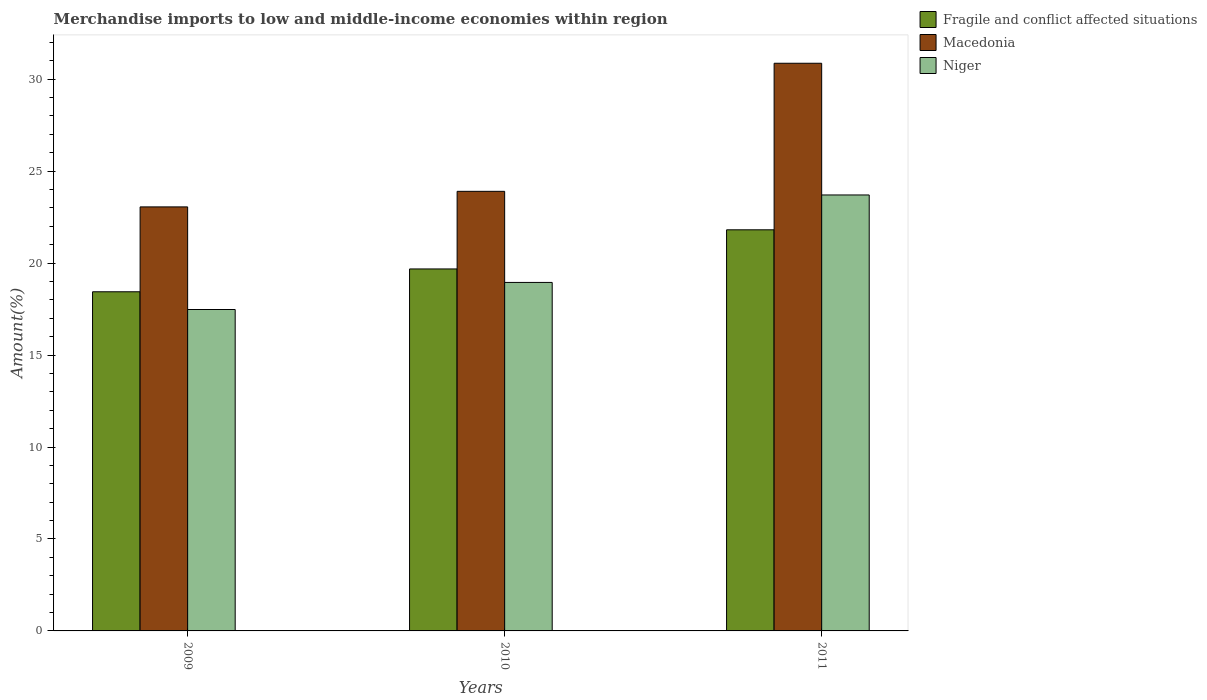How many different coloured bars are there?
Your response must be concise. 3. How many groups of bars are there?
Your answer should be compact. 3. Are the number of bars per tick equal to the number of legend labels?
Give a very brief answer. Yes. How many bars are there on the 1st tick from the left?
Your response must be concise. 3. What is the label of the 3rd group of bars from the left?
Your response must be concise. 2011. In how many cases, is the number of bars for a given year not equal to the number of legend labels?
Offer a terse response. 0. What is the percentage of amount earned from merchandise imports in Fragile and conflict affected situations in 2010?
Provide a short and direct response. 19.68. Across all years, what is the maximum percentage of amount earned from merchandise imports in Macedonia?
Give a very brief answer. 30.87. Across all years, what is the minimum percentage of amount earned from merchandise imports in Macedonia?
Give a very brief answer. 23.06. In which year was the percentage of amount earned from merchandise imports in Macedonia maximum?
Your response must be concise. 2011. In which year was the percentage of amount earned from merchandise imports in Niger minimum?
Provide a short and direct response. 2009. What is the total percentage of amount earned from merchandise imports in Macedonia in the graph?
Keep it short and to the point. 77.82. What is the difference between the percentage of amount earned from merchandise imports in Niger in 2009 and that in 2011?
Keep it short and to the point. -6.23. What is the difference between the percentage of amount earned from merchandise imports in Niger in 2011 and the percentage of amount earned from merchandise imports in Fragile and conflict affected situations in 2009?
Give a very brief answer. 5.26. What is the average percentage of amount earned from merchandise imports in Niger per year?
Your answer should be very brief. 20.04. In the year 2009, what is the difference between the percentage of amount earned from merchandise imports in Fragile and conflict affected situations and percentage of amount earned from merchandise imports in Macedonia?
Provide a succinct answer. -4.62. In how many years, is the percentage of amount earned from merchandise imports in Niger greater than 26 %?
Make the answer very short. 0. What is the ratio of the percentage of amount earned from merchandise imports in Macedonia in 2010 to that in 2011?
Offer a terse response. 0.77. What is the difference between the highest and the second highest percentage of amount earned from merchandise imports in Macedonia?
Your answer should be very brief. 6.96. What is the difference between the highest and the lowest percentage of amount earned from merchandise imports in Niger?
Provide a short and direct response. 6.23. Is the sum of the percentage of amount earned from merchandise imports in Niger in 2009 and 2010 greater than the maximum percentage of amount earned from merchandise imports in Fragile and conflict affected situations across all years?
Make the answer very short. Yes. What does the 3rd bar from the left in 2009 represents?
Your answer should be very brief. Niger. What does the 1st bar from the right in 2010 represents?
Keep it short and to the point. Niger. Is it the case that in every year, the sum of the percentage of amount earned from merchandise imports in Fragile and conflict affected situations and percentage of amount earned from merchandise imports in Niger is greater than the percentage of amount earned from merchandise imports in Macedonia?
Your answer should be compact. Yes. Are all the bars in the graph horizontal?
Your response must be concise. No. How many years are there in the graph?
Your answer should be very brief. 3. What is the difference between two consecutive major ticks on the Y-axis?
Provide a short and direct response. 5. Are the values on the major ticks of Y-axis written in scientific E-notation?
Provide a succinct answer. No. Does the graph contain any zero values?
Your response must be concise. No. Where does the legend appear in the graph?
Your answer should be very brief. Top right. How are the legend labels stacked?
Provide a short and direct response. Vertical. What is the title of the graph?
Offer a very short reply. Merchandise imports to low and middle-income economies within region. What is the label or title of the Y-axis?
Your answer should be compact. Amount(%). What is the Amount(%) in Fragile and conflict affected situations in 2009?
Make the answer very short. 18.44. What is the Amount(%) of Macedonia in 2009?
Provide a short and direct response. 23.06. What is the Amount(%) in Niger in 2009?
Keep it short and to the point. 17.48. What is the Amount(%) of Fragile and conflict affected situations in 2010?
Your answer should be very brief. 19.68. What is the Amount(%) of Macedonia in 2010?
Offer a terse response. 23.9. What is the Amount(%) in Niger in 2010?
Ensure brevity in your answer.  18.95. What is the Amount(%) of Fragile and conflict affected situations in 2011?
Ensure brevity in your answer.  21.81. What is the Amount(%) in Macedonia in 2011?
Provide a succinct answer. 30.87. What is the Amount(%) in Niger in 2011?
Offer a very short reply. 23.7. Across all years, what is the maximum Amount(%) in Fragile and conflict affected situations?
Ensure brevity in your answer.  21.81. Across all years, what is the maximum Amount(%) in Macedonia?
Offer a very short reply. 30.87. Across all years, what is the maximum Amount(%) in Niger?
Keep it short and to the point. 23.7. Across all years, what is the minimum Amount(%) of Fragile and conflict affected situations?
Offer a very short reply. 18.44. Across all years, what is the minimum Amount(%) of Macedonia?
Provide a short and direct response. 23.06. Across all years, what is the minimum Amount(%) of Niger?
Make the answer very short. 17.48. What is the total Amount(%) in Fragile and conflict affected situations in the graph?
Provide a succinct answer. 59.93. What is the total Amount(%) of Macedonia in the graph?
Keep it short and to the point. 77.82. What is the total Amount(%) in Niger in the graph?
Give a very brief answer. 60.13. What is the difference between the Amount(%) of Fragile and conflict affected situations in 2009 and that in 2010?
Offer a terse response. -1.24. What is the difference between the Amount(%) in Macedonia in 2009 and that in 2010?
Your response must be concise. -0.85. What is the difference between the Amount(%) of Niger in 2009 and that in 2010?
Your answer should be compact. -1.47. What is the difference between the Amount(%) in Fragile and conflict affected situations in 2009 and that in 2011?
Offer a very short reply. -3.37. What is the difference between the Amount(%) of Macedonia in 2009 and that in 2011?
Offer a very short reply. -7.81. What is the difference between the Amount(%) of Niger in 2009 and that in 2011?
Your response must be concise. -6.23. What is the difference between the Amount(%) of Fragile and conflict affected situations in 2010 and that in 2011?
Keep it short and to the point. -2.13. What is the difference between the Amount(%) in Macedonia in 2010 and that in 2011?
Offer a terse response. -6.96. What is the difference between the Amount(%) of Niger in 2010 and that in 2011?
Provide a short and direct response. -4.76. What is the difference between the Amount(%) of Fragile and conflict affected situations in 2009 and the Amount(%) of Macedonia in 2010?
Provide a succinct answer. -5.46. What is the difference between the Amount(%) in Fragile and conflict affected situations in 2009 and the Amount(%) in Niger in 2010?
Provide a succinct answer. -0.51. What is the difference between the Amount(%) of Macedonia in 2009 and the Amount(%) of Niger in 2010?
Provide a short and direct response. 4.11. What is the difference between the Amount(%) of Fragile and conflict affected situations in 2009 and the Amount(%) of Macedonia in 2011?
Provide a succinct answer. -12.42. What is the difference between the Amount(%) in Fragile and conflict affected situations in 2009 and the Amount(%) in Niger in 2011?
Keep it short and to the point. -5.26. What is the difference between the Amount(%) of Macedonia in 2009 and the Amount(%) of Niger in 2011?
Ensure brevity in your answer.  -0.65. What is the difference between the Amount(%) of Fragile and conflict affected situations in 2010 and the Amount(%) of Macedonia in 2011?
Keep it short and to the point. -11.18. What is the difference between the Amount(%) of Fragile and conflict affected situations in 2010 and the Amount(%) of Niger in 2011?
Offer a terse response. -4.02. What is the difference between the Amount(%) of Macedonia in 2010 and the Amount(%) of Niger in 2011?
Your response must be concise. 0.2. What is the average Amount(%) of Fragile and conflict affected situations per year?
Keep it short and to the point. 19.98. What is the average Amount(%) in Macedonia per year?
Provide a short and direct response. 25.94. What is the average Amount(%) of Niger per year?
Give a very brief answer. 20.04. In the year 2009, what is the difference between the Amount(%) in Fragile and conflict affected situations and Amount(%) in Macedonia?
Ensure brevity in your answer.  -4.62. In the year 2009, what is the difference between the Amount(%) in Fragile and conflict affected situations and Amount(%) in Niger?
Your answer should be very brief. 0.96. In the year 2009, what is the difference between the Amount(%) in Macedonia and Amount(%) in Niger?
Make the answer very short. 5.58. In the year 2010, what is the difference between the Amount(%) in Fragile and conflict affected situations and Amount(%) in Macedonia?
Your response must be concise. -4.22. In the year 2010, what is the difference between the Amount(%) in Fragile and conflict affected situations and Amount(%) in Niger?
Your answer should be compact. 0.73. In the year 2010, what is the difference between the Amount(%) in Macedonia and Amount(%) in Niger?
Your answer should be compact. 4.95. In the year 2011, what is the difference between the Amount(%) in Fragile and conflict affected situations and Amount(%) in Macedonia?
Make the answer very short. -9.06. In the year 2011, what is the difference between the Amount(%) in Fragile and conflict affected situations and Amount(%) in Niger?
Provide a succinct answer. -1.89. In the year 2011, what is the difference between the Amount(%) of Macedonia and Amount(%) of Niger?
Offer a terse response. 7.16. What is the ratio of the Amount(%) of Fragile and conflict affected situations in 2009 to that in 2010?
Provide a short and direct response. 0.94. What is the ratio of the Amount(%) of Macedonia in 2009 to that in 2010?
Keep it short and to the point. 0.96. What is the ratio of the Amount(%) in Niger in 2009 to that in 2010?
Your response must be concise. 0.92. What is the ratio of the Amount(%) of Fragile and conflict affected situations in 2009 to that in 2011?
Provide a short and direct response. 0.85. What is the ratio of the Amount(%) in Macedonia in 2009 to that in 2011?
Offer a very short reply. 0.75. What is the ratio of the Amount(%) in Niger in 2009 to that in 2011?
Make the answer very short. 0.74. What is the ratio of the Amount(%) in Fragile and conflict affected situations in 2010 to that in 2011?
Offer a very short reply. 0.9. What is the ratio of the Amount(%) in Macedonia in 2010 to that in 2011?
Make the answer very short. 0.77. What is the ratio of the Amount(%) of Niger in 2010 to that in 2011?
Ensure brevity in your answer.  0.8. What is the difference between the highest and the second highest Amount(%) in Fragile and conflict affected situations?
Give a very brief answer. 2.13. What is the difference between the highest and the second highest Amount(%) in Macedonia?
Offer a very short reply. 6.96. What is the difference between the highest and the second highest Amount(%) of Niger?
Provide a short and direct response. 4.76. What is the difference between the highest and the lowest Amount(%) in Fragile and conflict affected situations?
Your answer should be compact. 3.37. What is the difference between the highest and the lowest Amount(%) of Macedonia?
Your answer should be very brief. 7.81. What is the difference between the highest and the lowest Amount(%) in Niger?
Your response must be concise. 6.23. 